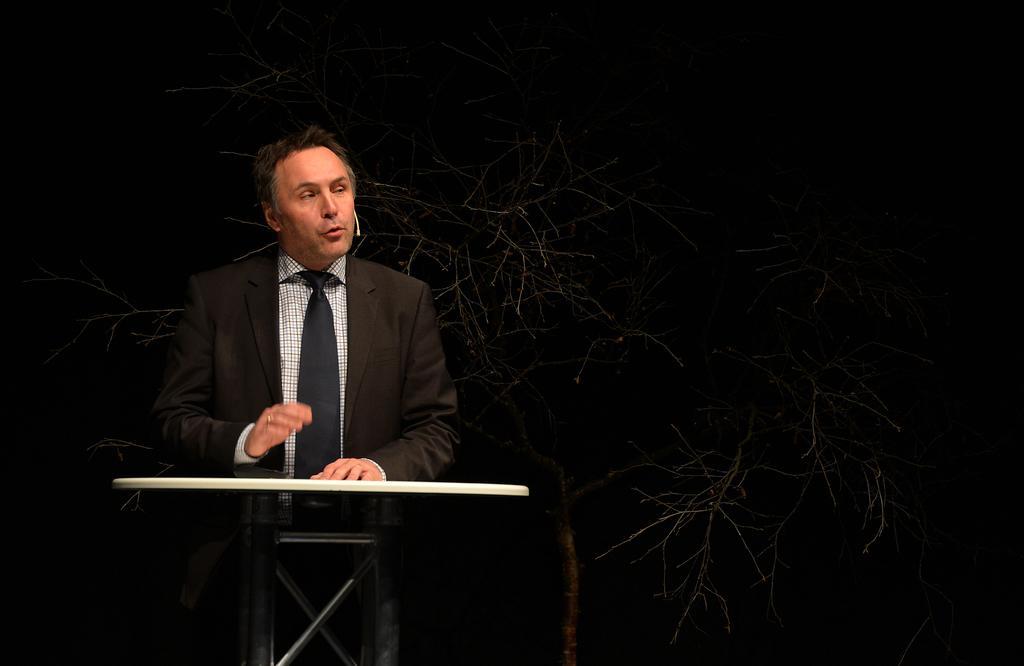How would you summarize this image in a sentence or two? In this picture we can see a person wearing a mouth microphone and standing in front of an object. We can see a tree with branches and stems. There is the dark view visible in the background. 